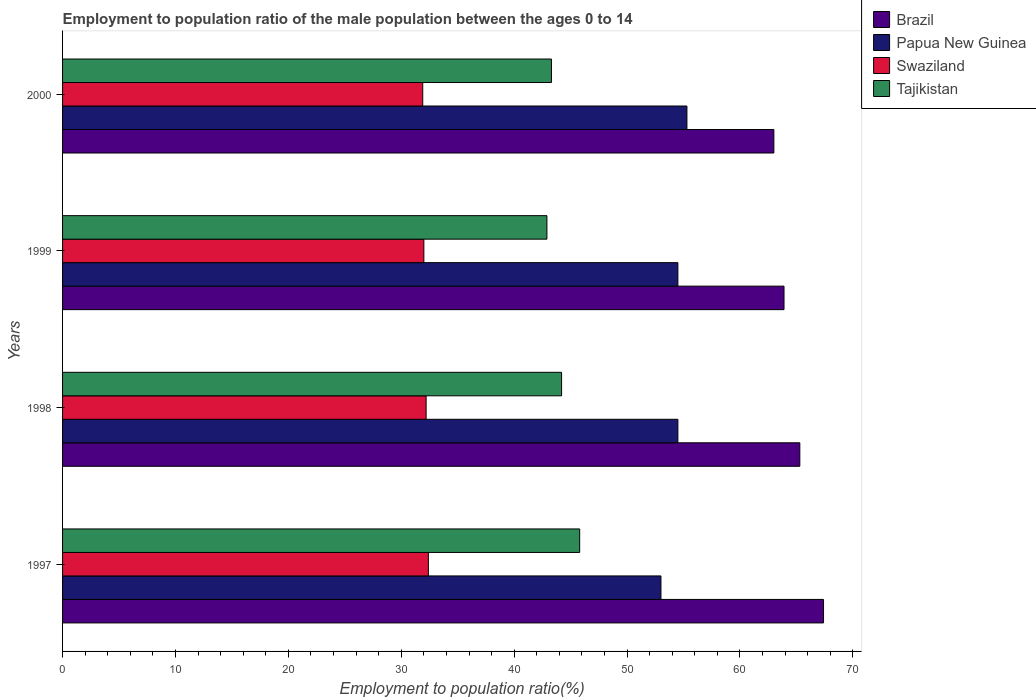How many different coloured bars are there?
Offer a terse response. 4. Are the number of bars per tick equal to the number of legend labels?
Offer a very short reply. Yes. Are the number of bars on each tick of the Y-axis equal?
Your response must be concise. Yes. How many bars are there on the 2nd tick from the top?
Provide a short and direct response. 4. How many bars are there on the 3rd tick from the bottom?
Make the answer very short. 4. In how many cases, is the number of bars for a given year not equal to the number of legend labels?
Keep it short and to the point. 0. What is the employment to population ratio in Swaziland in 1998?
Give a very brief answer. 32.2. Across all years, what is the maximum employment to population ratio in Papua New Guinea?
Your response must be concise. 55.3. Across all years, what is the minimum employment to population ratio in Brazil?
Ensure brevity in your answer.  63. In which year was the employment to population ratio in Papua New Guinea maximum?
Give a very brief answer. 2000. What is the total employment to population ratio in Swaziland in the graph?
Make the answer very short. 128.5. What is the difference between the employment to population ratio in Tajikistan in 1998 and that in 1999?
Give a very brief answer. 1.3. What is the difference between the employment to population ratio in Brazil in 2000 and the employment to population ratio in Swaziland in 1997?
Your answer should be very brief. 30.6. What is the average employment to population ratio in Tajikistan per year?
Your answer should be very brief. 44.05. In the year 2000, what is the difference between the employment to population ratio in Swaziland and employment to population ratio in Brazil?
Your answer should be compact. -31.1. In how many years, is the employment to population ratio in Tajikistan greater than 20 %?
Offer a very short reply. 4. What is the ratio of the employment to population ratio in Papua New Guinea in 1997 to that in 2000?
Make the answer very short. 0.96. Is the employment to population ratio in Brazil in 1998 less than that in 2000?
Ensure brevity in your answer.  No. What is the difference between the highest and the second highest employment to population ratio in Tajikistan?
Keep it short and to the point. 1.6. What is the difference between the highest and the lowest employment to population ratio in Swaziland?
Your answer should be very brief. 0.5. In how many years, is the employment to population ratio in Tajikistan greater than the average employment to population ratio in Tajikistan taken over all years?
Keep it short and to the point. 2. Is it the case that in every year, the sum of the employment to population ratio in Swaziland and employment to population ratio in Tajikistan is greater than the sum of employment to population ratio in Brazil and employment to population ratio in Papua New Guinea?
Make the answer very short. No. What does the 1st bar from the top in 1998 represents?
Ensure brevity in your answer.  Tajikistan. What does the 2nd bar from the bottom in 2000 represents?
Offer a very short reply. Papua New Guinea. Is it the case that in every year, the sum of the employment to population ratio in Tajikistan and employment to population ratio in Brazil is greater than the employment to population ratio in Papua New Guinea?
Keep it short and to the point. Yes. How many years are there in the graph?
Give a very brief answer. 4. Does the graph contain any zero values?
Offer a terse response. No. How many legend labels are there?
Your response must be concise. 4. What is the title of the graph?
Offer a terse response. Employment to population ratio of the male population between the ages 0 to 14. What is the label or title of the Y-axis?
Offer a very short reply. Years. What is the Employment to population ratio(%) of Brazil in 1997?
Provide a succinct answer. 67.4. What is the Employment to population ratio(%) of Papua New Guinea in 1997?
Your answer should be very brief. 53. What is the Employment to population ratio(%) in Swaziland in 1997?
Your answer should be very brief. 32.4. What is the Employment to population ratio(%) in Tajikistan in 1997?
Ensure brevity in your answer.  45.8. What is the Employment to population ratio(%) of Brazil in 1998?
Give a very brief answer. 65.3. What is the Employment to population ratio(%) in Papua New Guinea in 1998?
Your answer should be very brief. 54.5. What is the Employment to population ratio(%) in Swaziland in 1998?
Ensure brevity in your answer.  32.2. What is the Employment to population ratio(%) in Tajikistan in 1998?
Provide a succinct answer. 44.2. What is the Employment to population ratio(%) in Brazil in 1999?
Your response must be concise. 63.9. What is the Employment to population ratio(%) of Papua New Guinea in 1999?
Your answer should be very brief. 54.5. What is the Employment to population ratio(%) in Swaziland in 1999?
Your response must be concise. 32. What is the Employment to population ratio(%) of Tajikistan in 1999?
Provide a succinct answer. 42.9. What is the Employment to population ratio(%) of Papua New Guinea in 2000?
Ensure brevity in your answer.  55.3. What is the Employment to population ratio(%) of Swaziland in 2000?
Your response must be concise. 31.9. What is the Employment to population ratio(%) of Tajikistan in 2000?
Make the answer very short. 43.3. Across all years, what is the maximum Employment to population ratio(%) of Brazil?
Offer a very short reply. 67.4. Across all years, what is the maximum Employment to population ratio(%) in Papua New Guinea?
Your answer should be compact. 55.3. Across all years, what is the maximum Employment to population ratio(%) in Swaziland?
Make the answer very short. 32.4. Across all years, what is the maximum Employment to population ratio(%) in Tajikistan?
Offer a terse response. 45.8. Across all years, what is the minimum Employment to population ratio(%) in Papua New Guinea?
Your answer should be very brief. 53. Across all years, what is the minimum Employment to population ratio(%) of Swaziland?
Offer a very short reply. 31.9. Across all years, what is the minimum Employment to population ratio(%) in Tajikistan?
Provide a succinct answer. 42.9. What is the total Employment to population ratio(%) in Brazil in the graph?
Ensure brevity in your answer.  259.6. What is the total Employment to population ratio(%) in Papua New Guinea in the graph?
Provide a short and direct response. 217.3. What is the total Employment to population ratio(%) in Swaziland in the graph?
Ensure brevity in your answer.  128.5. What is the total Employment to population ratio(%) of Tajikistan in the graph?
Your response must be concise. 176.2. What is the difference between the Employment to population ratio(%) in Brazil in 1997 and that in 1998?
Your response must be concise. 2.1. What is the difference between the Employment to population ratio(%) in Tajikistan in 1997 and that in 1998?
Your response must be concise. 1.6. What is the difference between the Employment to population ratio(%) in Papua New Guinea in 1997 and that in 1999?
Provide a succinct answer. -1.5. What is the difference between the Employment to population ratio(%) in Tajikistan in 1997 and that in 1999?
Your answer should be compact. 2.9. What is the difference between the Employment to population ratio(%) in Brazil in 1997 and that in 2000?
Give a very brief answer. 4.4. What is the difference between the Employment to population ratio(%) of Papua New Guinea in 1997 and that in 2000?
Provide a short and direct response. -2.3. What is the difference between the Employment to population ratio(%) in Swaziland in 1997 and that in 2000?
Provide a short and direct response. 0.5. What is the difference between the Employment to population ratio(%) of Tajikistan in 1997 and that in 2000?
Keep it short and to the point. 2.5. What is the difference between the Employment to population ratio(%) of Swaziland in 1998 and that in 1999?
Keep it short and to the point. 0.2. What is the difference between the Employment to population ratio(%) in Papua New Guinea in 1998 and that in 2000?
Your answer should be compact. -0.8. What is the difference between the Employment to population ratio(%) of Brazil in 1999 and that in 2000?
Make the answer very short. 0.9. What is the difference between the Employment to population ratio(%) in Tajikistan in 1999 and that in 2000?
Offer a very short reply. -0.4. What is the difference between the Employment to population ratio(%) of Brazil in 1997 and the Employment to population ratio(%) of Papua New Guinea in 1998?
Give a very brief answer. 12.9. What is the difference between the Employment to population ratio(%) of Brazil in 1997 and the Employment to population ratio(%) of Swaziland in 1998?
Offer a terse response. 35.2. What is the difference between the Employment to population ratio(%) in Brazil in 1997 and the Employment to population ratio(%) in Tajikistan in 1998?
Provide a succinct answer. 23.2. What is the difference between the Employment to population ratio(%) of Papua New Guinea in 1997 and the Employment to population ratio(%) of Swaziland in 1998?
Your response must be concise. 20.8. What is the difference between the Employment to population ratio(%) of Papua New Guinea in 1997 and the Employment to population ratio(%) of Tajikistan in 1998?
Give a very brief answer. 8.8. What is the difference between the Employment to population ratio(%) in Swaziland in 1997 and the Employment to population ratio(%) in Tajikistan in 1998?
Offer a very short reply. -11.8. What is the difference between the Employment to population ratio(%) of Brazil in 1997 and the Employment to population ratio(%) of Papua New Guinea in 1999?
Your answer should be very brief. 12.9. What is the difference between the Employment to population ratio(%) of Brazil in 1997 and the Employment to population ratio(%) of Swaziland in 1999?
Provide a short and direct response. 35.4. What is the difference between the Employment to population ratio(%) in Papua New Guinea in 1997 and the Employment to population ratio(%) in Tajikistan in 1999?
Offer a very short reply. 10.1. What is the difference between the Employment to population ratio(%) in Brazil in 1997 and the Employment to population ratio(%) in Swaziland in 2000?
Provide a short and direct response. 35.5. What is the difference between the Employment to population ratio(%) in Brazil in 1997 and the Employment to population ratio(%) in Tajikistan in 2000?
Make the answer very short. 24.1. What is the difference between the Employment to population ratio(%) of Papua New Guinea in 1997 and the Employment to population ratio(%) of Swaziland in 2000?
Make the answer very short. 21.1. What is the difference between the Employment to population ratio(%) of Brazil in 1998 and the Employment to population ratio(%) of Papua New Guinea in 1999?
Your answer should be very brief. 10.8. What is the difference between the Employment to population ratio(%) in Brazil in 1998 and the Employment to population ratio(%) in Swaziland in 1999?
Make the answer very short. 33.3. What is the difference between the Employment to population ratio(%) of Brazil in 1998 and the Employment to population ratio(%) of Tajikistan in 1999?
Offer a very short reply. 22.4. What is the difference between the Employment to population ratio(%) of Papua New Guinea in 1998 and the Employment to population ratio(%) of Tajikistan in 1999?
Provide a short and direct response. 11.6. What is the difference between the Employment to population ratio(%) of Swaziland in 1998 and the Employment to population ratio(%) of Tajikistan in 1999?
Offer a terse response. -10.7. What is the difference between the Employment to population ratio(%) of Brazil in 1998 and the Employment to population ratio(%) of Swaziland in 2000?
Make the answer very short. 33.4. What is the difference between the Employment to population ratio(%) of Brazil in 1998 and the Employment to population ratio(%) of Tajikistan in 2000?
Your answer should be very brief. 22. What is the difference between the Employment to population ratio(%) in Papua New Guinea in 1998 and the Employment to population ratio(%) in Swaziland in 2000?
Keep it short and to the point. 22.6. What is the difference between the Employment to population ratio(%) of Papua New Guinea in 1998 and the Employment to population ratio(%) of Tajikistan in 2000?
Offer a very short reply. 11.2. What is the difference between the Employment to population ratio(%) of Swaziland in 1998 and the Employment to population ratio(%) of Tajikistan in 2000?
Give a very brief answer. -11.1. What is the difference between the Employment to population ratio(%) in Brazil in 1999 and the Employment to population ratio(%) in Papua New Guinea in 2000?
Give a very brief answer. 8.6. What is the difference between the Employment to population ratio(%) in Brazil in 1999 and the Employment to population ratio(%) in Swaziland in 2000?
Make the answer very short. 32. What is the difference between the Employment to population ratio(%) in Brazil in 1999 and the Employment to population ratio(%) in Tajikistan in 2000?
Provide a succinct answer. 20.6. What is the difference between the Employment to population ratio(%) in Papua New Guinea in 1999 and the Employment to population ratio(%) in Swaziland in 2000?
Your answer should be very brief. 22.6. What is the difference between the Employment to population ratio(%) of Swaziland in 1999 and the Employment to population ratio(%) of Tajikistan in 2000?
Your answer should be compact. -11.3. What is the average Employment to population ratio(%) in Brazil per year?
Your answer should be very brief. 64.9. What is the average Employment to population ratio(%) of Papua New Guinea per year?
Keep it short and to the point. 54.33. What is the average Employment to population ratio(%) in Swaziland per year?
Offer a very short reply. 32.12. What is the average Employment to population ratio(%) of Tajikistan per year?
Provide a short and direct response. 44.05. In the year 1997, what is the difference between the Employment to population ratio(%) of Brazil and Employment to population ratio(%) of Tajikistan?
Your answer should be compact. 21.6. In the year 1997, what is the difference between the Employment to population ratio(%) in Papua New Guinea and Employment to population ratio(%) in Swaziland?
Ensure brevity in your answer.  20.6. In the year 1997, what is the difference between the Employment to population ratio(%) of Swaziland and Employment to population ratio(%) of Tajikistan?
Offer a terse response. -13.4. In the year 1998, what is the difference between the Employment to population ratio(%) of Brazil and Employment to population ratio(%) of Papua New Guinea?
Provide a succinct answer. 10.8. In the year 1998, what is the difference between the Employment to population ratio(%) in Brazil and Employment to population ratio(%) in Swaziland?
Offer a very short reply. 33.1. In the year 1998, what is the difference between the Employment to population ratio(%) of Brazil and Employment to population ratio(%) of Tajikistan?
Ensure brevity in your answer.  21.1. In the year 1998, what is the difference between the Employment to population ratio(%) in Papua New Guinea and Employment to population ratio(%) in Swaziland?
Make the answer very short. 22.3. In the year 1999, what is the difference between the Employment to population ratio(%) of Brazil and Employment to population ratio(%) of Swaziland?
Provide a succinct answer. 31.9. In the year 1999, what is the difference between the Employment to population ratio(%) in Papua New Guinea and Employment to population ratio(%) in Tajikistan?
Ensure brevity in your answer.  11.6. In the year 1999, what is the difference between the Employment to population ratio(%) of Swaziland and Employment to population ratio(%) of Tajikistan?
Provide a short and direct response. -10.9. In the year 2000, what is the difference between the Employment to population ratio(%) in Brazil and Employment to population ratio(%) in Swaziland?
Keep it short and to the point. 31.1. In the year 2000, what is the difference between the Employment to population ratio(%) of Papua New Guinea and Employment to population ratio(%) of Swaziland?
Your response must be concise. 23.4. What is the ratio of the Employment to population ratio(%) in Brazil in 1997 to that in 1998?
Your answer should be compact. 1.03. What is the ratio of the Employment to population ratio(%) in Papua New Guinea in 1997 to that in 1998?
Your answer should be compact. 0.97. What is the ratio of the Employment to population ratio(%) of Swaziland in 1997 to that in 1998?
Your response must be concise. 1.01. What is the ratio of the Employment to population ratio(%) of Tajikistan in 1997 to that in 1998?
Your answer should be compact. 1.04. What is the ratio of the Employment to population ratio(%) in Brazil in 1997 to that in 1999?
Your answer should be compact. 1.05. What is the ratio of the Employment to population ratio(%) of Papua New Guinea in 1997 to that in 1999?
Keep it short and to the point. 0.97. What is the ratio of the Employment to population ratio(%) in Swaziland in 1997 to that in 1999?
Offer a terse response. 1.01. What is the ratio of the Employment to population ratio(%) of Tajikistan in 1997 to that in 1999?
Provide a succinct answer. 1.07. What is the ratio of the Employment to population ratio(%) in Brazil in 1997 to that in 2000?
Make the answer very short. 1.07. What is the ratio of the Employment to population ratio(%) of Papua New Guinea in 1997 to that in 2000?
Offer a terse response. 0.96. What is the ratio of the Employment to population ratio(%) of Swaziland in 1997 to that in 2000?
Offer a terse response. 1.02. What is the ratio of the Employment to population ratio(%) in Tajikistan in 1997 to that in 2000?
Keep it short and to the point. 1.06. What is the ratio of the Employment to population ratio(%) in Brazil in 1998 to that in 1999?
Your answer should be compact. 1.02. What is the ratio of the Employment to population ratio(%) in Swaziland in 1998 to that in 1999?
Provide a short and direct response. 1.01. What is the ratio of the Employment to population ratio(%) of Tajikistan in 1998 to that in 1999?
Give a very brief answer. 1.03. What is the ratio of the Employment to population ratio(%) of Brazil in 1998 to that in 2000?
Your answer should be very brief. 1.04. What is the ratio of the Employment to population ratio(%) in Papua New Guinea in 1998 to that in 2000?
Your answer should be compact. 0.99. What is the ratio of the Employment to population ratio(%) of Swaziland in 1998 to that in 2000?
Make the answer very short. 1.01. What is the ratio of the Employment to population ratio(%) in Tajikistan in 1998 to that in 2000?
Give a very brief answer. 1.02. What is the ratio of the Employment to population ratio(%) in Brazil in 1999 to that in 2000?
Make the answer very short. 1.01. What is the ratio of the Employment to population ratio(%) in Papua New Guinea in 1999 to that in 2000?
Give a very brief answer. 0.99. What is the ratio of the Employment to population ratio(%) of Tajikistan in 1999 to that in 2000?
Provide a short and direct response. 0.99. What is the difference between the highest and the lowest Employment to population ratio(%) of Brazil?
Ensure brevity in your answer.  4.4. What is the difference between the highest and the lowest Employment to population ratio(%) in Papua New Guinea?
Your answer should be compact. 2.3. What is the difference between the highest and the lowest Employment to population ratio(%) of Tajikistan?
Offer a very short reply. 2.9. 